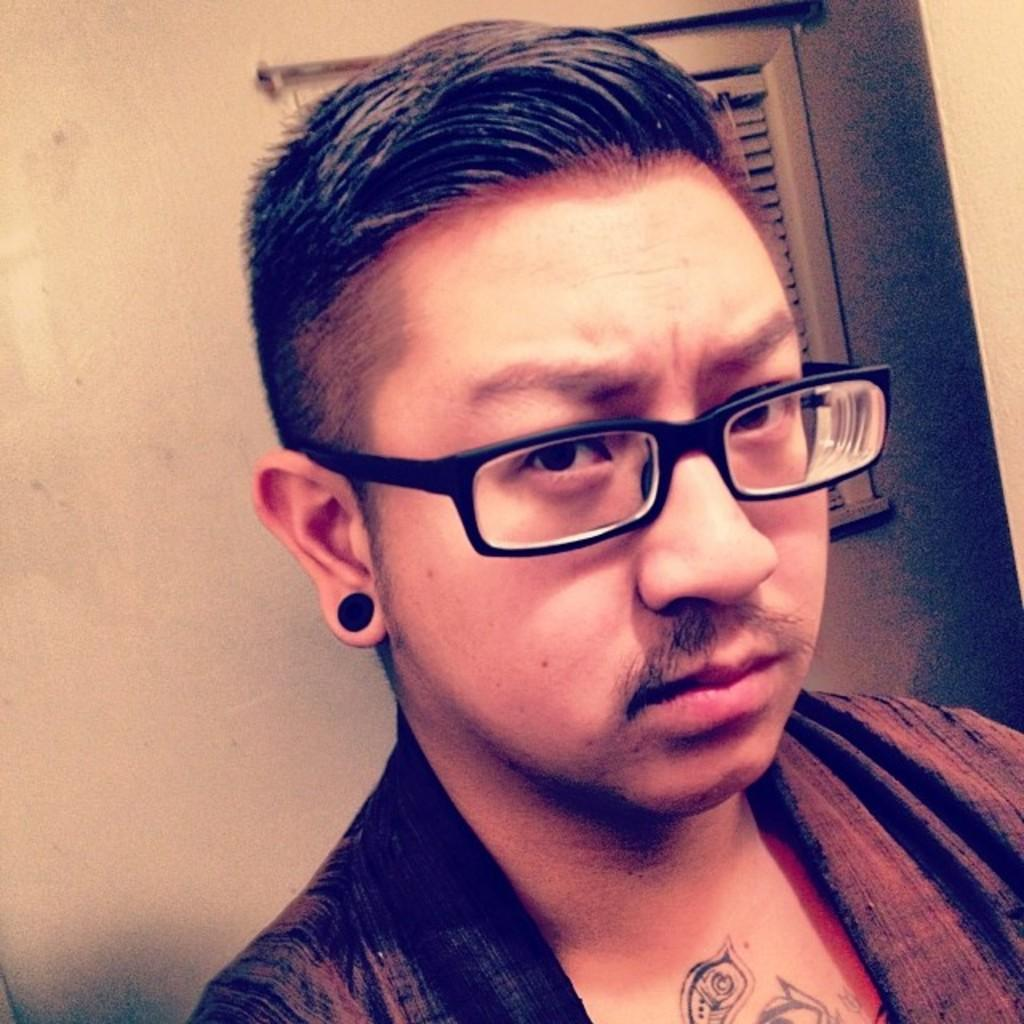What is present in the image? There is a person in the image. Can you describe the person's appearance? The person is wearing clothes and spectacles. What type of winter clothing is the person wearing in the image? There is no reference to winter clothing or any specific season in the image, so it is not possible to answer that question. 